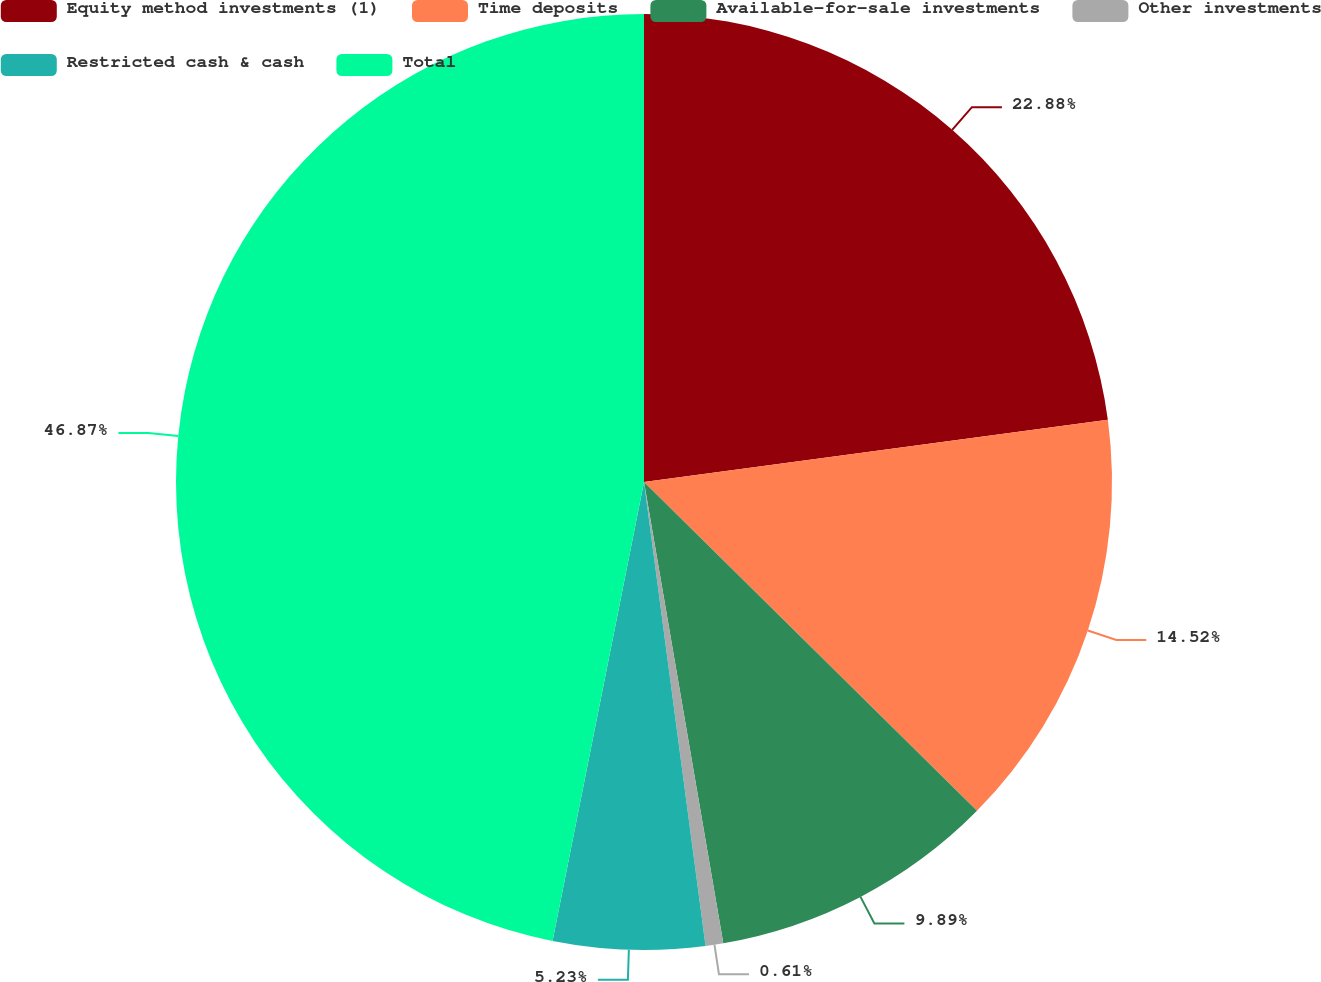<chart> <loc_0><loc_0><loc_500><loc_500><pie_chart><fcel>Equity method investments (1)<fcel>Time deposits<fcel>Available-for-sale investments<fcel>Other investments<fcel>Restricted cash & cash<fcel>Total<nl><fcel>22.88%<fcel>14.52%<fcel>9.89%<fcel>0.61%<fcel>5.23%<fcel>46.87%<nl></chart> 